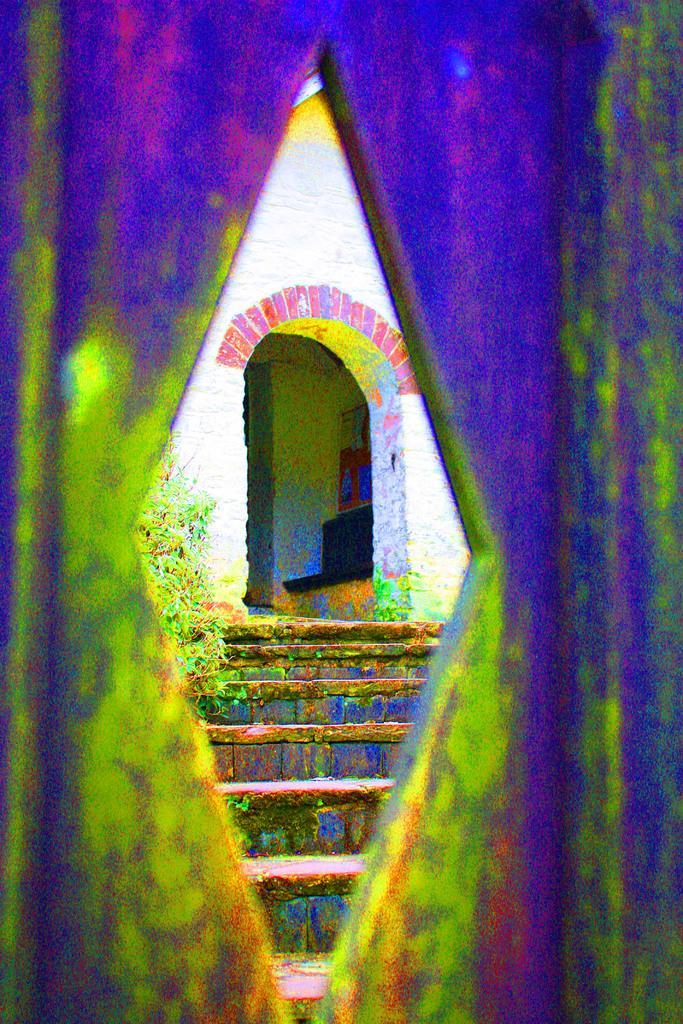Please provide a concise description of this image. In this image in the foreground there is a wall, and on the wall there are some colors and in the background there is a staircase and wall and some objects and plant and also there are some colors. 